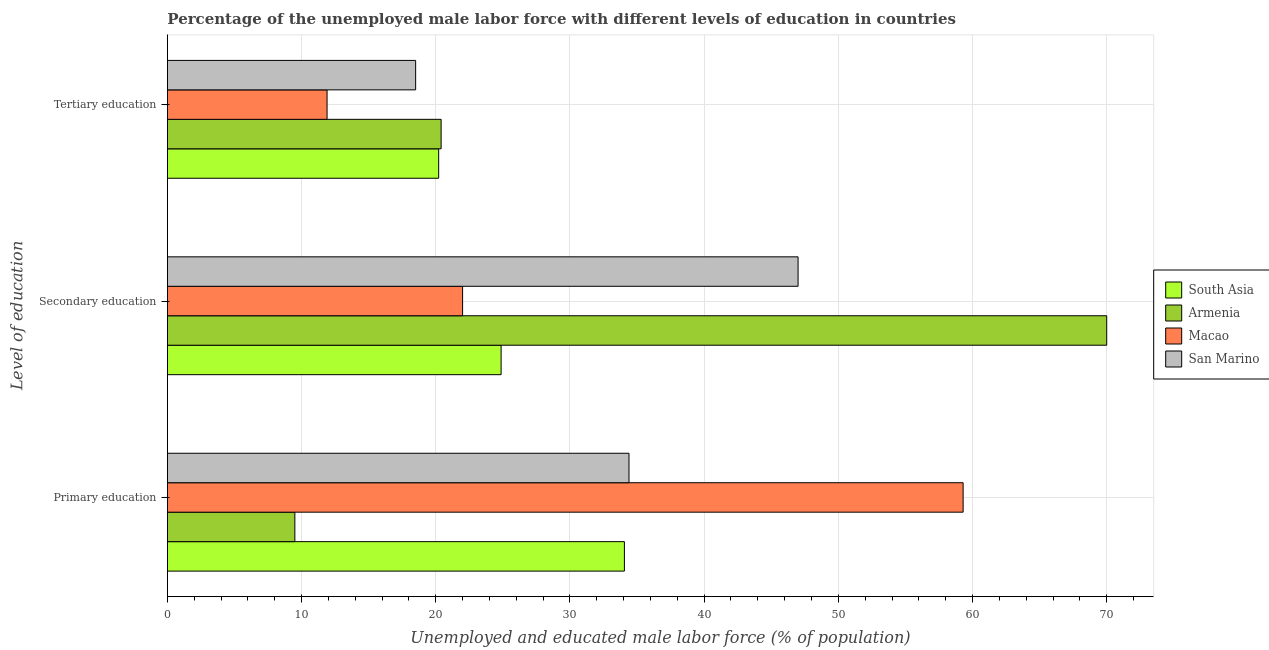How many groups of bars are there?
Provide a short and direct response. 3. Are the number of bars per tick equal to the number of legend labels?
Provide a succinct answer. Yes. How many bars are there on the 1st tick from the top?
Provide a succinct answer. 4. What is the percentage of male labor force who received primary education in South Asia?
Ensure brevity in your answer.  34.06. Across all countries, what is the maximum percentage of male labor force who received secondary education?
Provide a succinct answer. 70. Across all countries, what is the minimum percentage of male labor force who received secondary education?
Offer a very short reply. 22. In which country was the percentage of male labor force who received primary education maximum?
Offer a terse response. Macao. In which country was the percentage of male labor force who received secondary education minimum?
Offer a very short reply. Macao. What is the total percentage of male labor force who received tertiary education in the graph?
Offer a terse response. 71.02. What is the difference between the percentage of male labor force who received secondary education in South Asia and that in Macao?
Give a very brief answer. 2.87. What is the difference between the percentage of male labor force who received secondary education in South Asia and the percentage of male labor force who received tertiary education in Macao?
Your answer should be very brief. 12.97. What is the average percentage of male labor force who received tertiary education per country?
Offer a very short reply. 17.75. What is the difference between the percentage of male labor force who received primary education and percentage of male labor force who received tertiary education in Armenia?
Give a very brief answer. -10.9. What is the ratio of the percentage of male labor force who received primary education in San Marino to that in Armenia?
Offer a very short reply. 3.62. Is the percentage of male labor force who received primary education in Macao less than that in South Asia?
Your response must be concise. No. Is the difference between the percentage of male labor force who received secondary education in Macao and Armenia greater than the difference between the percentage of male labor force who received primary education in Macao and Armenia?
Provide a succinct answer. No. What is the difference between the highest and the second highest percentage of male labor force who received tertiary education?
Offer a very short reply. 0.18. In how many countries, is the percentage of male labor force who received tertiary education greater than the average percentage of male labor force who received tertiary education taken over all countries?
Provide a short and direct response. 3. What does the 3rd bar from the top in Secondary education represents?
Your answer should be very brief. Armenia. What does the 2nd bar from the bottom in Tertiary education represents?
Make the answer very short. Armenia. What is the difference between two consecutive major ticks on the X-axis?
Your answer should be compact. 10. Are the values on the major ticks of X-axis written in scientific E-notation?
Keep it short and to the point. No. Does the graph contain any zero values?
Keep it short and to the point. No. Does the graph contain grids?
Offer a terse response. Yes. Where does the legend appear in the graph?
Provide a short and direct response. Center right. How many legend labels are there?
Your answer should be compact. 4. What is the title of the graph?
Keep it short and to the point. Percentage of the unemployed male labor force with different levels of education in countries. What is the label or title of the X-axis?
Your answer should be compact. Unemployed and educated male labor force (% of population). What is the label or title of the Y-axis?
Ensure brevity in your answer.  Level of education. What is the Unemployed and educated male labor force (% of population) in South Asia in Primary education?
Your response must be concise. 34.06. What is the Unemployed and educated male labor force (% of population) in Armenia in Primary education?
Keep it short and to the point. 9.5. What is the Unemployed and educated male labor force (% of population) in Macao in Primary education?
Your response must be concise. 59.3. What is the Unemployed and educated male labor force (% of population) in San Marino in Primary education?
Offer a very short reply. 34.4. What is the Unemployed and educated male labor force (% of population) in South Asia in Secondary education?
Keep it short and to the point. 24.87. What is the Unemployed and educated male labor force (% of population) in Armenia in Secondary education?
Your response must be concise. 70. What is the Unemployed and educated male labor force (% of population) of Macao in Secondary education?
Provide a succinct answer. 22. What is the Unemployed and educated male labor force (% of population) in San Marino in Secondary education?
Offer a terse response. 47. What is the Unemployed and educated male labor force (% of population) of South Asia in Tertiary education?
Make the answer very short. 20.22. What is the Unemployed and educated male labor force (% of population) in Armenia in Tertiary education?
Keep it short and to the point. 20.4. What is the Unemployed and educated male labor force (% of population) of Macao in Tertiary education?
Your response must be concise. 11.9. What is the Unemployed and educated male labor force (% of population) of San Marino in Tertiary education?
Your response must be concise. 18.5. Across all Level of education, what is the maximum Unemployed and educated male labor force (% of population) in South Asia?
Make the answer very short. 34.06. Across all Level of education, what is the maximum Unemployed and educated male labor force (% of population) of Macao?
Keep it short and to the point. 59.3. Across all Level of education, what is the minimum Unemployed and educated male labor force (% of population) of South Asia?
Offer a very short reply. 20.22. Across all Level of education, what is the minimum Unemployed and educated male labor force (% of population) of Armenia?
Ensure brevity in your answer.  9.5. Across all Level of education, what is the minimum Unemployed and educated male labor force (% of population) in Macao?
Give a very brief answer. 11.9. What is the total Unemployed and educated male labor force (% of population) in South Asia in the graph?
Offer a very short reply. 79.15. What is the total Unemployed and educated male labor force (% of population) in Armenia in the graph?
Give a very brief answer. 99.9. What is the total Unemployed and educated male labor force (% of population) of Macao in the graph?
Ensure brevity in your answer.  93.2. What is the total Unemployed and educated male labor force (% of population) in San Marino in the graph?
Your answer should be very brief. 99.9. What is the difference between the Unemployed and educated male labor force (% of population) of South Asia in Primary education and that in Secondary education?
Your answer should be very brief. 9.19. What is the difference between the Unemployed and educated male labor force (% of population) of Armenia in Primary education and that in Secondary education?
Give a very brief answer. -60.5. What is the difference between the Unemployed and educated male labor force (% of population) in Macao in Primary education and that in Secondary education?
Give a very brief answer. 37.3. What is the difference between the Unemployed and educated male labor force (% of population) of San Marino in Primary education and that in Secondary education?
Keep it short and to the point. -12.6. What is the difference between the Unemployed and educated male labor force (% of population) of South Asia in Primary education and that in Tertiary education?
Keep it short and to the point. 13.84. What is the difference between the Unemployed and educated male labor force (% of population) in Macao in Primary education and that in Tertiary education?
Give a very brief answer. 47.4. What is the difference between the Unemployed and educated male labor force (% of population) in San Marino in Primary education and that in Tertiary education?
Offer a very short reply. 15.9. What is the difference between the Unemployed and educated male labor force (% of population) in South Asia in Secondary education and that in Tertiary education?
Provide a short and direct response. 4.65. What is the difference between the Unemployed and educated male labor force (% of population) of Armenia in Secondary education and that in Tertiary education?
Keep it short and to the point. 49.6. What is the difference between the Unemployed and educated male labor force (% of population) of San Marino in Secondary education and that in Tertiary education?
Keep it short and to the point. 28.5. What is the difference between the Unemployed and educated male labor force (% of population) in South Asia in Primary education and the Unemployed and educated male labor force (% of population) in Armenia in Secondary education?
Your answer should be very brief. -35.94. What is the difference between the Unemployed and educated male labor force (% of population) in South Asia in Primary education and the Unemployed and educated male labor force (% of population) in Macao in Secondary education?
Give a very brief answer. 12.06. What is the difference between the Unemployed and educated male labor force (% of population) of South Asia in Primary education and the Unemployed and educated male labor force (% of population) of San Marino in Secondary education?
Provide a succinct answer. -12.94. What is the difference between the Unemployed and educated male labor force (% of population) of Armenia in Primary education and the Unemployed and educated male labor force (% of population) of San Marino in Secondary education?
Make the answer very short. -37.5. What is the difference between the Unemployed and educated male labor force (% of population) in South Asia in Primary education and the Unemployed and educated male labor force (% of population) in Armenia in Tertiary education?
Offer a very short reply. 13.66. What is the difference between the Unemployed and educated male labor force (% of population) in South Asia in Primary education and the Unemployed and educated male labor force (% of population) in Macao in Tertiary education?
Ensure brevity in your answer.  22.16. What is the difference between the Unemployed and educated male labor force (% of population) of South Asia in Primary education and the Unemployed and educated male labor force (% of population) of San Marino in Tertiary education?
Provide a succinct answer. 15.56. What is the difference between the Unemployed and educated male labor force (% of population) in Armenia in Primary education and the Unemployed and educated male labor force (% of population) in Macao in Tertiary education?
Make the answer very short. -2.4. What is the difference between the Unemployed and educated male labor force (% of population) in Armenia in Primary education and the Unemployed and educated male labor force (% of population) in San Marino in Tertiary education?
Offer a very short reply. -9. What is the difference between the Unemployed and educated male labor force (% of population) of Macao in Primary education and the Unemployed and educated male labor force (% of population) of San Marino in Tertiary education?
Provide a short and direct response. 40.8. What is the difference between the Unemployed and educated male labor force (% of population) in South Asia in Secondary education and the Unemployed and educated male labor force (% of population) in Armenia in Tertiary education?
Your answer should be very brief. 4.47. What is the difference between the Unemployed and educated male labor force (% of population) of South Asia in Secondary education and the Unemployed and educated male labor force (% of population) of Macao in Tertiary education?
Your answer should be compact. 12.97. What is the difference between the Unemployed and educated male labor force (% of population) of South Asia in Secondary education and the Unemployed and educated male labor force (% of population) of San Marino in Tertiary education?
Offer a terse response. 6.37. What is the difference between the Unemployed and educated male labor force (% of population) in Armenia in Secondary education and the Unemployed and educated male labor force (% of population) in Macao in Tertiary education?
Ensure brevity in your answer.  58.1. What is the difference between the Unemployed and educated male labor force (% of population) of Armenia in Secondary education and the Unemployed and educated male labor force (% of population) of San Marino in Tertiary education?
Make the answer very short. 51.5. What is the difference between the Unemployed and educated male labor force (% of population) in Macao in Secondary education and the Unemployed and educated male labor force (% of population) in San Marino in Tertiary education?
Ensure brevity in your answer.  3.5. What is the average Unemployed and educated male labor force (% of population) in South Asia per Level of education?
Keep it short and to the point. 26.38. What is the average Unemployed and educated male labor force (% of population) in Armenia per Level of education?
Provide a succinct answer. 33.3. What is the average Unemployed and educated male labor force (% of population) in Macao per Level of education?
Give a very brief answer. 31.07. What is the average Unemployed and educated male labor force (% of population) of San Marino per Level of education?
Keep it short and to the point. 33.3. What is the difference between the Unemployed and educated male labor force (% of population) in South Asia and Unemployed and educated male labor force (% of population) in Armenia in Primary education?
Your answer should be very brief. 24.56. What is the difference between the Unemployed and educated male labor force (% of population) in South Asia and Unemployed and educated male labor force (% of population) in Macao in Primary education?
Give a very brief answer. -25.24. What is the difference between the Unemployed and educated male labor force (% of population) in South Asia and Unemployed and educated male labor force (% of population) in San Marino in Primary education?
Keep it short and to the point. -0.34. What is the difference between the Unemployed and educated male labor force (% of population) in Armenia and Unemployed and educated male labor force (% of population) in Macao in Primary education?
Provide a short and direct response. -49.8. What is the difference between the Unemployed and educated male labor force (% of population) of Armenia and Unemployed and educated male labor force (% of population) of San Marino in Primary education?
Keep it short and to the point. -24.9. What is the difference between the Unemployed and educated male labor force (% of population) of Macao and Unemployed and educated male labor force (% of population) of San Marino in Primary education?
Your response must be concise. 24.9. What is the difference between the Unemployed and educated male labor force (% of population) of South Asia and Unemployed and educated male labor force (% of population) of Armenia in Secondary education?
Offer a very short reply. -45.13. What is the difference between the Unemployed and educated male labor force (% of population) of South Asia and Unemployed and educated male labor force (% of population) of Macao in Secondary education?
Ensure brevity in your answer.  2.87. What is the difference between the Unemployed and educated male labor force (% of population) of South Asia and Unemployed and educated male labor force (% of population) of San Marino in Secondary education?
Keep it short and to the point. -22.13. What is the difference between the Unemployed and educated male labor force (% of population) of Armenia and Unemployed and educated male labor force (% of population) of Macao in Secondary education?
Offer a very short reply. 48. What is the difference between the Unemployed and educated male labor force (% of population) of Armenia and Unemployed and educated male labor force (% of population) of San Marino in Secondary education?
Your answer should be very brief. 23. What is the difference between the Unemployed and educated male labor force (% of population) in South Asia and Unemployed and educated male labor force (% of population) in Armenia in Tertiary education?
Offer a terse response. -0.18. What is the difference between the Unemployed and educated male labor force (% of population) of South Asia and Unemployed and educated male labor force (% of population) of Macao in Tertiary education?
Make the answer very short. 8.32. What is the difference between the Unemployed and educated male labor force (% of population) of South Asia and Unemployed and educated male labor force (% of population) of San Marino in Tertiary education?
Provide a succinct answer. 1.72. What is the difference between the Unemployed and educated male labor force (% of population) of Armenia and Unemployed and educated male labor force (% of population) of Macao in Tertiary education?
Ensure brevity in your answer.  8.5. What is the difference between the Unemployed and educated male labor force (% of population) in Armenia and Unemployed and educated male labor force (% of population) in San Marino in Tertiary education?
Offer a terse response. 1.9. What is the difference between the Unemployed and educated male labor force (% of population) of Macao and Unemployed and educated male labor force (% of population) of San Marino in Tertiary education?
Offer a terse response. -6.6. What is the ratio of the Unemployed and educated male labor force (% of population) of South Asia in Primary education to that in Secondary education?
Keep it short and to the point. 1.37. What is the ratio of the Unemployed and educated male labor force (% of population) of Armenia in Primary education to that in Secondary education?
Offer a terse response. 0.14. What is the ratio of the Unemployed and educated male labor force (% of population) in Macao in Primary education to that in Secondary education?
Provide a succinct answer. 2.7. What is the ratio of the Unemployed and educated male labor force (% of population) in San Marino in Primary education to that in Secondary education?
Provide a succinct answer. 0.73. What is the ratio of the Unemployed and educated male labor force (% of population) of South Asia in Primary education to that in Tertiary education?
Provide a short and direct response. 1.68. What is the ratio of the Unemployed and educated male labor force (% of population) of Armenia in Primary education to that in Tertiary education?
Give a very brief answer. 0.47. What is the ratio of the Unemployed and educated male labor force (% of population) in Macao in Primary education to that in Tertiary education?
Make the answer very short. 4.98. What is the ratio of the Unemployed and educated male labor force (% of population) of San Marino in Primary education to that in Tertiary education?
Keep it short and to the point. 1.86. What is the ratio of the Unemployed and educated male labor force (% of population) in South Asia in Secondary education to that in Tertiary education?
Make the answer very short. 1.23. What is the ratio of the Unemployed and educated male labor force (% of population) in Armenia in Secondary education to that in Tertiary education?
Provide a succinct answer. 3.43. What is the ratio of the Unemployed and educated male labor force (% of population) in Macao in Secondary education to that in Tertiary education?
Provide a succinct answer. 1.85. What is the ratio of the Unemployed and educated male labor force (% of population) in San Marino in Secondary education to that in Tertiary education?
Offer a very short reply. 2.54. What is the difference between the highest and the second highest Unemployed and educated male labor force (% of population) of South Asia?
Provide a succinct answer. 9.19. What is the difference between the highest and the second highest Unemployed and educated male labor force (% of population) in Armenia?
Offer a terse response. 49.6. What is the difference between the highest and the second highest Unemployed and educated male labor force (% of population) of Macao?
Offer a very short reply. 37.3. What is the difference between the highest and the lowest Unemployed and educated male labor force (% of population) in South Asia?
Offer a terse response. 13.84. What is the difference between the highest and the lowest Unemployed and educated male labor force (% of population) in Armenia?
Your response must be concise. 60.5. What is the difference between the highest and the lowest Unemployed and educated male labor force (% of population) in Macao?
Your response must be concise. 47.4. What is the difference between the highest and the lowest Unemployed and educated male labor force (% of population) of San Marino?
Provide a succinct answer. 28.5. 